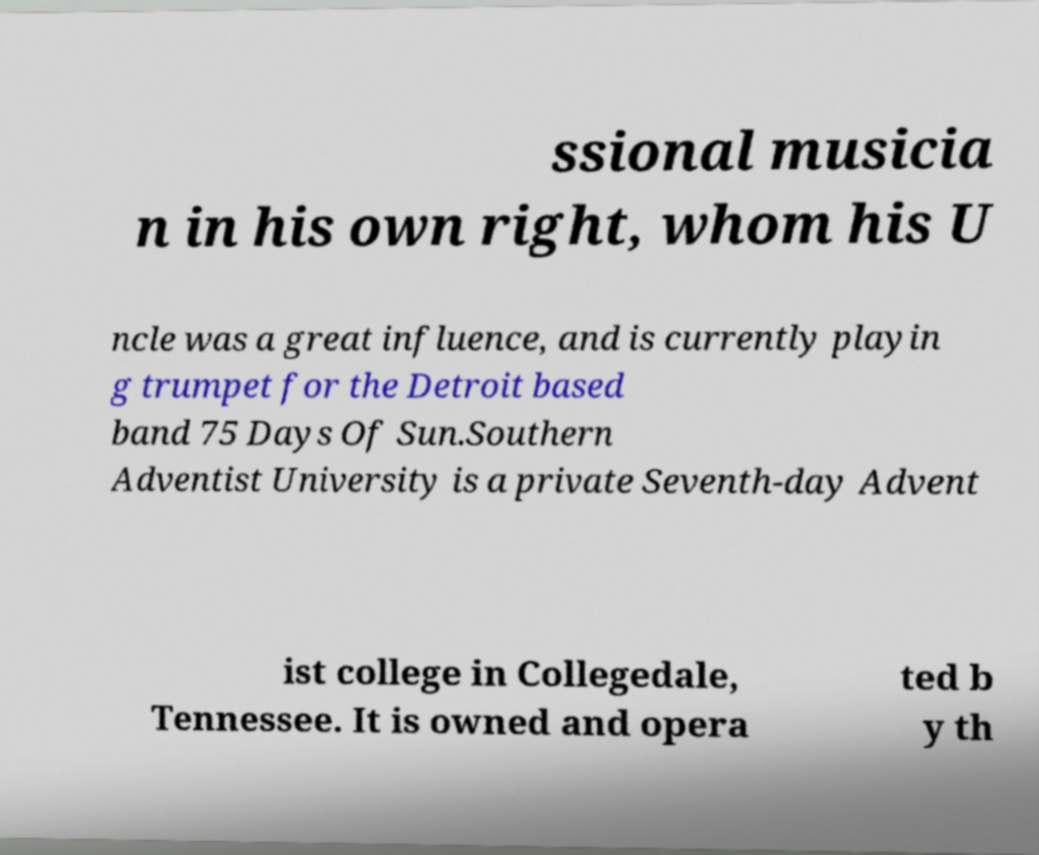For documentation purposes, I need the text within this image transcribed. Could you provide that? ssional musicia n in his own right, whom his U ncle was a great influence, and is currently playin g trumpet for the Detroit based band 75 Days Of Sun.Southern Adventist University is a private Seventh-day Advent ist college in Collegedale, Tennessee. It is owned and opera ted b y th 